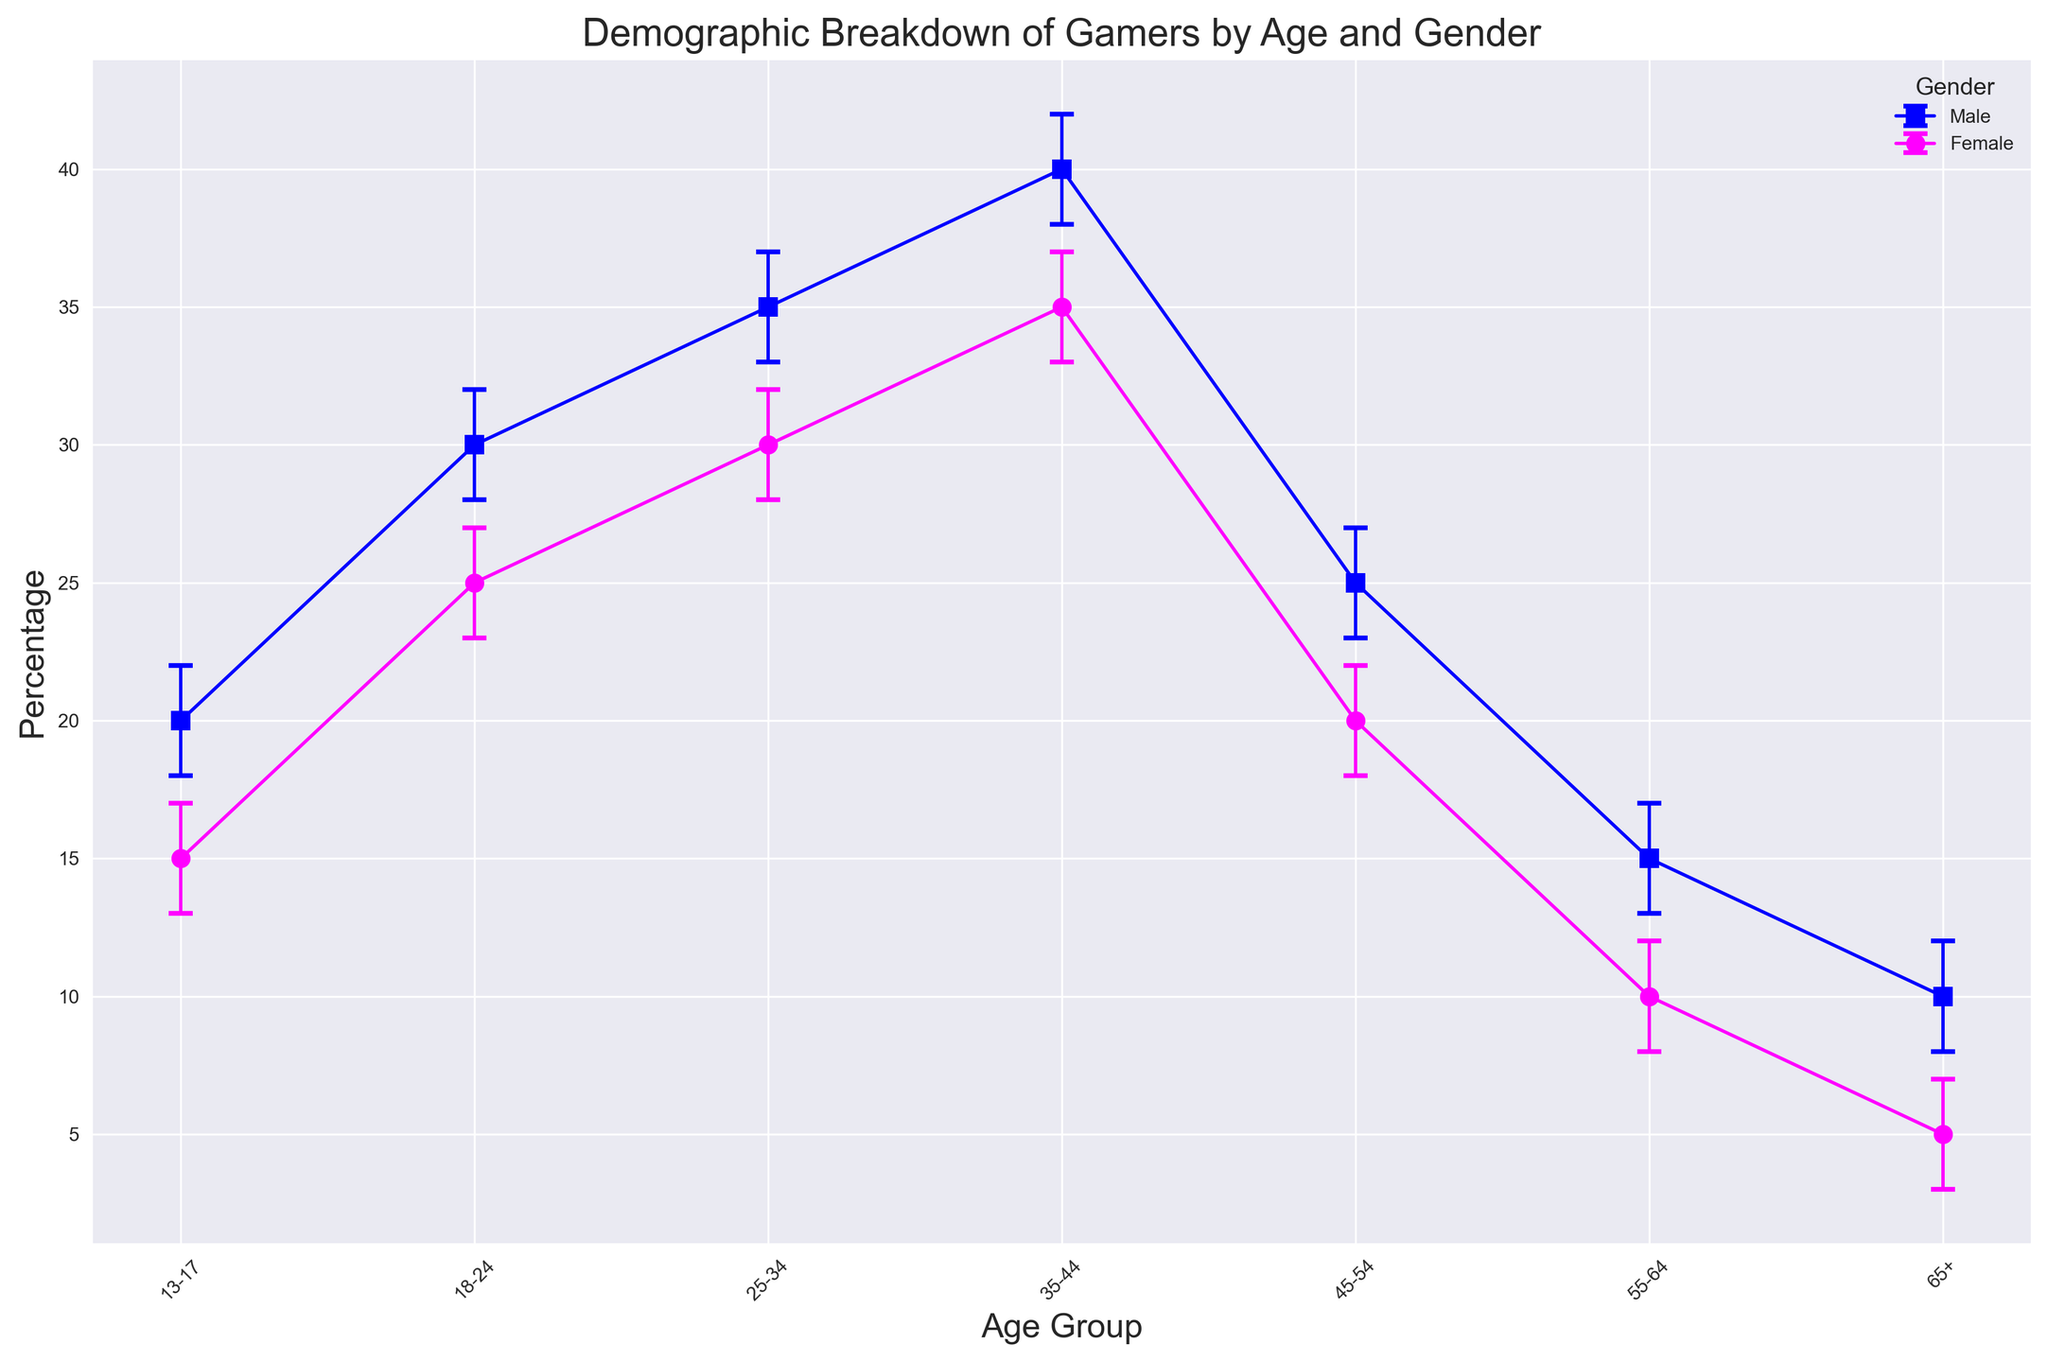What is the age group with the highest percentage of female gamers? The plot shows the percentage of female gamers across different age groups. By looking at the data points and error bars, the age group 35-44 has the highest percentage of female gamers at 35%.
Answer: 35-44 Which gender has a higher percentage in the age group 18-24? By comparing the markers for male and female in the age group 18-24 on the plot, the male percentage is higher (30%) compared to the female percentage (25%).
Answer: Male What is the difference in the percentage of male and female gamers in the 45-54 age group? For the 45-54 age group, the percentage of male gamers is 25% and female gamers is 20%. The difference is calculated as 25% - 20% = 5%.
Answer: 5% Which age group has the smallest difference in percentage between male and female gamers? By inspecting the data points for each age group, we note that the 25-34 age group has the percentages 35% (male) and 30% (female). The difference is 5%, which is smaller than the differences in other age groups.
Answer: 25-34 What is the average percentage of female gamers across all age groups? Sum the female percentages for all age groups and divide by the number of age groups: (15 + 25 + 30 + 35 + 20 + 10 + 5) / 7 = 140 / 7 = 20.
Answer: 20 Is the percentage of female gamers in the 65+ age group within the confidence interval of male gamers in the same age group? The percentage of female gamers in the 65+ age group is 5% with a confidence interval of (3, 7). The percentage of male gamers in the same age group is 10% with a confidence interval of (8, 12). Since 5% lies outside the male's confidence interval, it is not within.
Answer: No For the age group 35-44, how much wider is the confidence interval for females compared to males? The confidence interval for males is (38, 42) which is 42 - 38 = 4 percentage points wide, and for females, it is (33, 37) which is also 37 - 33 = 4 percentage points wide. Thus, there is no difference in width.
Answer: 0 Which age group has the lowest percentage of gamers regardless of gender? Both the male and female data points in the 65+ age group show the lowest percentages (10% for males and 5% for females).
Answer: 65+ What is the combined percentage of male and female gamers in the 25-34 age group? The combined percentage of male and female gamers is the sum of the two percentages: 35% (male) + 30% (female) = 65%.
Answer: 65 In which age group is there the greatest balance between male and female gamers? Balance is greatest where the percentages are closest. The 13-17 age group shows percentages of 20% (male) and 15% (female), a small difference of 5%, which is among the smallest differences and suggests a relatively balanced distribution.
Answer: 13-17 